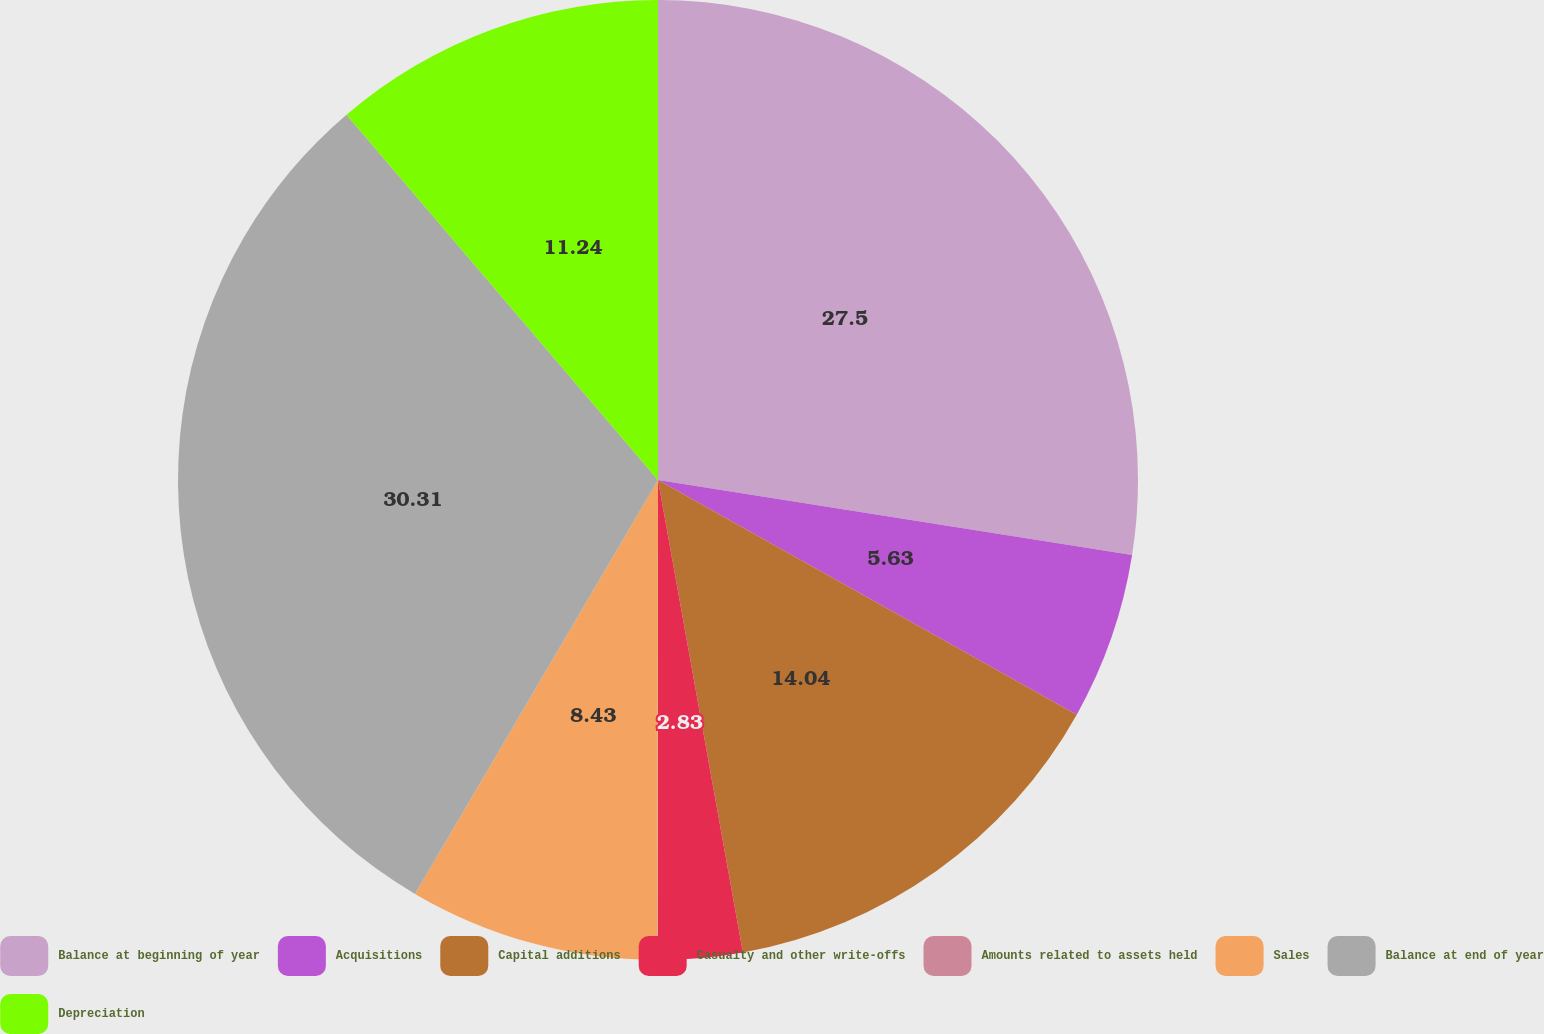Convert chart. <chart><loc_0><loc_0><loc_500><loc_500><pie_chart><fcel>Balance at beginning of year<fcel>Acquisitions<fcel>Capital additions<fcel>Casualty and other write-offs<fcel>Amounts related to assets held<fcel>Sales<fcel>Balance at end of year<fcel>Depreciation<nl><fcel>27.5%<fcel>5.63%<fcel>14.04%<fcel>2.83%<fcel>0.02%<fcel>8.43%<fcel>30.31%<fcel>11.24%<nl></chart> 